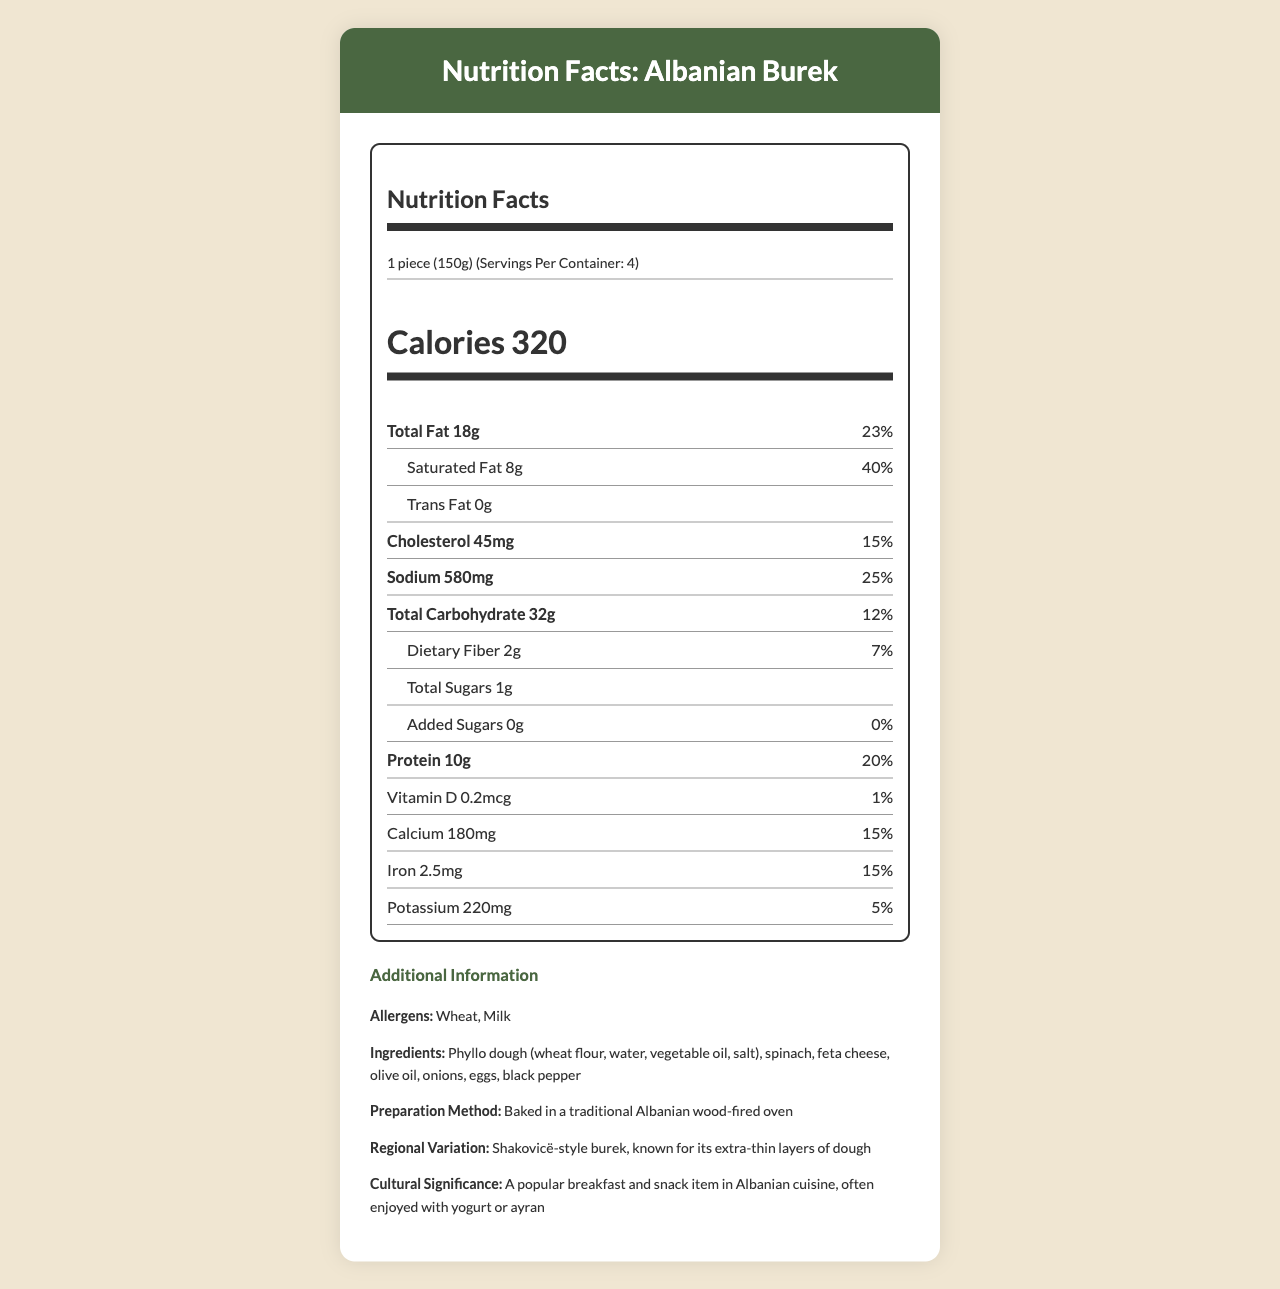what is the serving size? The serving size is indicated at the beginning of the document under "Nutrition Facts".
Answer: 1 piece (150g) how many calories are in one serving? The number of calories per serving is stated as "Calories 320".
Answer: 320 what percentage of the daily value is the total fat? The daily value percentage for total fat is listed as 23%.
Answer: 23% how much protein does one serving contain? The protein content per serving is listed as 10g.
Answer: 10g what are the allergens listed in the document? The allergens listed in the "Additional Information" section are Wheat and Milk.
Answer: Wheat, Milk which nutrient has the highest daily value percentage? A. Saturated Fat B. Cholesterol C. Sodium D. Iron Saturated Fat has a daily value percentage of 40%, which is the highest among the listed nutrients.
Answer: A how much calcium is in one serving? A. 120mg B. 160mg C. 180mg D. 220mg Calcium content per serving is listed as 180mg, which is option C.
Answer: C is there any trans fat in the burek? The document lists Trans Fat as 0g, indicating there is none present.
Answer: No what ingredients are used to make this burek? The ingredients are detailed in the "Additional Information" section.
Answer: Phyllo dough (wheat flour, water, vegetable oil, salt), spinach, feta cheese, olive oil, onions, eggs, black pepper how is this traditional Albanian burek prepared? The preparation method is described in the "Additional Information" section.
Answer: Baked in a traditional Albanian wood-fired oven what is the cultural significance of this burek? The cultural significance is described in the "Additional Information" section.
Answer: A popular breakfast and snack item in Albanian cuisine, often enjoyed with yogurt or ayran can one serving cover your daily requirement for dietary fiber? The daily value percentage for dietary fiber is listed as 7%, which means it does not cover the daily requirement.
Answer: No summarize the information provided in the document. The document details the nutritional content per serving of burek, including essential nutrients and daily values, and provides additional context on allergens, preparation, and cultural importance.
Answer: The document provides nutrition facts for a traditional Albanian burek with spinach and feta, highlighting serving size, calorie content, various nutrients with their respective values and daily percentages, and additional information about allergens, ingredients, preparation method, regional variation, and cultural significance. how popular is this burek in Albania? The document does not provide specific details on the popularity level of the burek in Albania.
Answer: Not enough information 